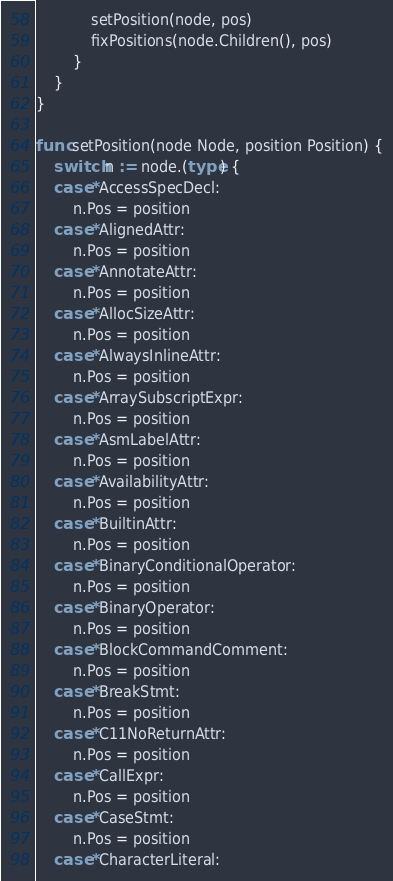Convert code to text. <code><loc_0><loc_0><loc_500><loc_500><_Go_>			setPosition(node, pos)
			fixPositions(node.Children(), pos)
		}
	}
}

func setPosition(node Node, position Position) {
	switch n := node.(type) {
	case *AccessSpecDecl:
		n.Pos = position
	case *AlignedAttr:
		n.Pos = position
	case *AnnotateAttr:
		n.Pos = position
	case *AllocSizeAttr:
		n.Pos = position
	case *AlwaysInlineAttr:
		n.Pos = position
	case *ArraySubscriptExpr:
		n.Pos = position
	case *AsmLabelAttr:
		n.Pos = position
	case *AvailabilityAttr:
		n.Pos = position
	case *BuiltinAttr:
		n.Pos = position
	case *BinaryConditionalOperator:
		n.Pos = position
	case *BinaryOperator:
		n.Pos = position
	case *BlockCommandComment:
		n.Pos = position
	case *BreakStmt:
		n.Pos = position
	case *C11NoReturnAttr:
		n.Pos = position
	case *CallExpr:
		n.Pos = position
	case *CaseStmt:
		n.Pos = position
	case *CharacterLiteral:</code> 